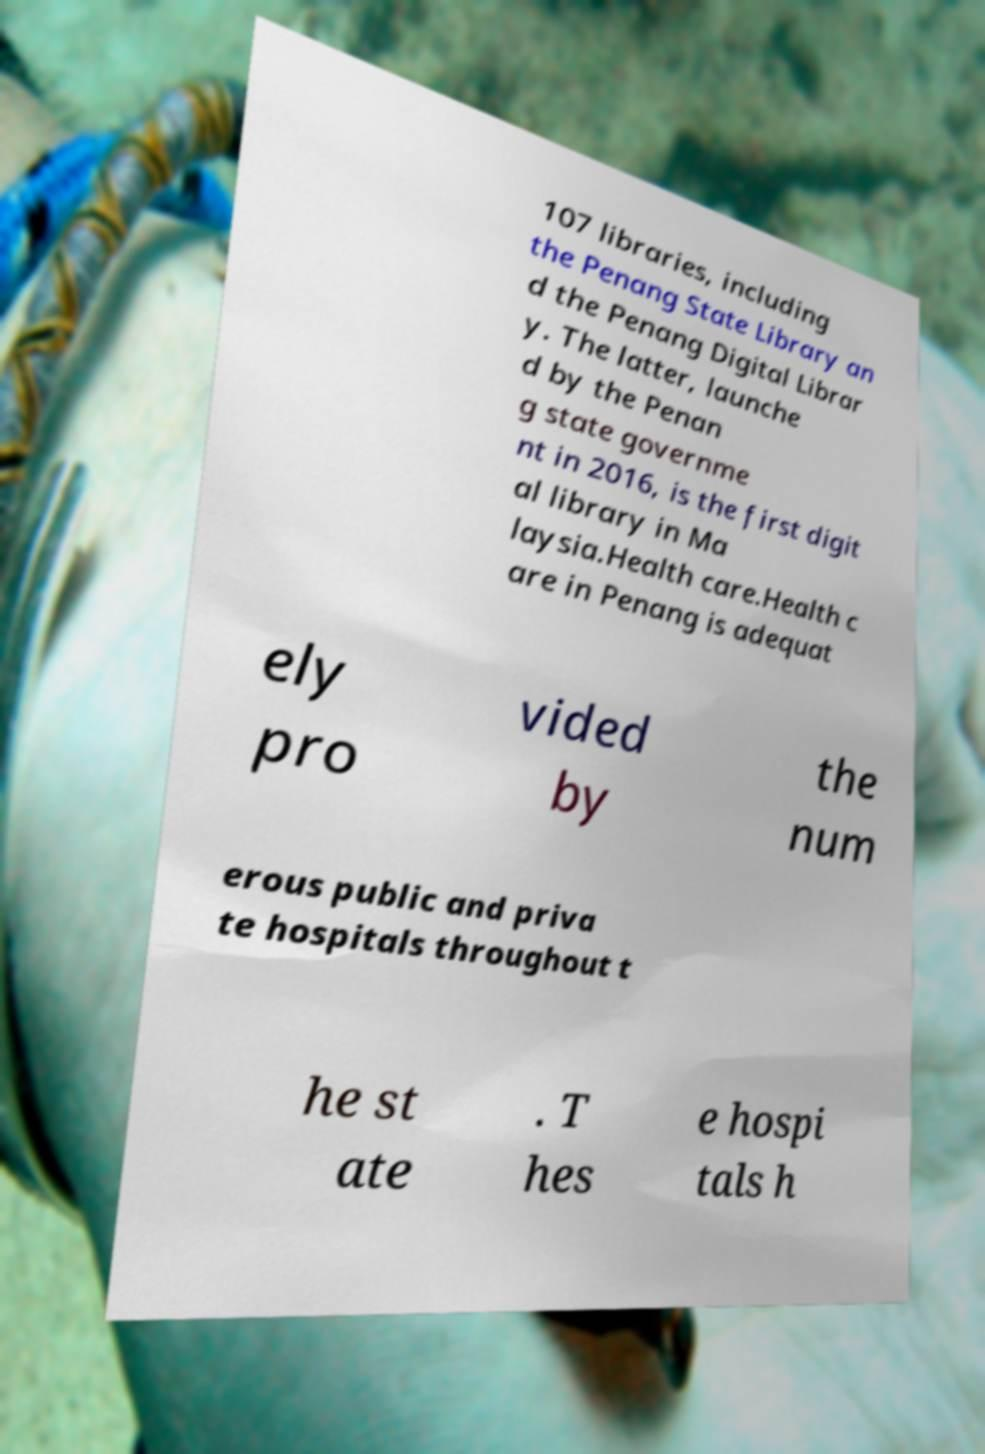Could you assist in decoding the text presented in this image and type it out clearly? 107 libraries, including the Penang State Library an d the Penang Digital Librar y. The latter, launche d by the Penan g state governme nt in 2016, is the first digit al library in Ma laysia.Health care.Health c are in Penang is adequat ely pro vided by the num erous public and priva te hospitals throughout t he st ate . T hes e hospi tals h 